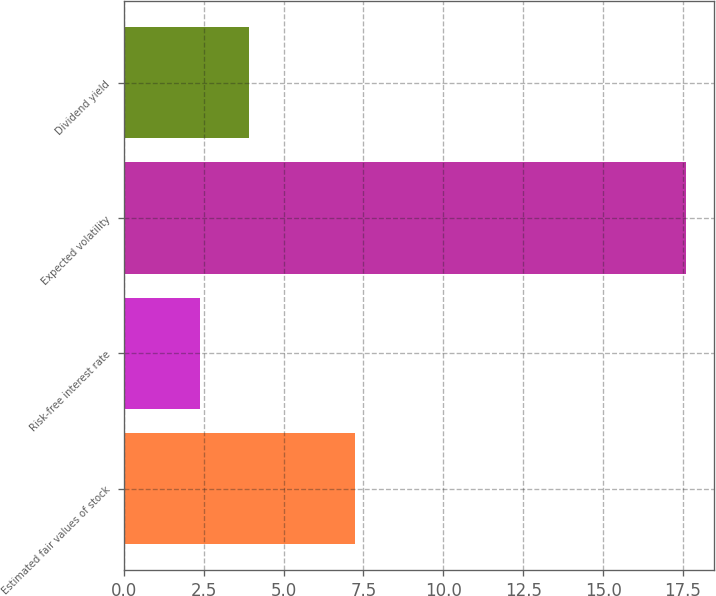Convert chart to OTSL. <chart><loc_0><loc_0><loc_500><loc_500><bar_chart><fcel>Estimated fair values of stock<fcel>Risk-free interest rate<fcel>Expected volatility<fcel>Dividend yield<nl><fcel>7.24<fcel>2.4<fcel>17.6<fcel>3.92<nl></chart> 